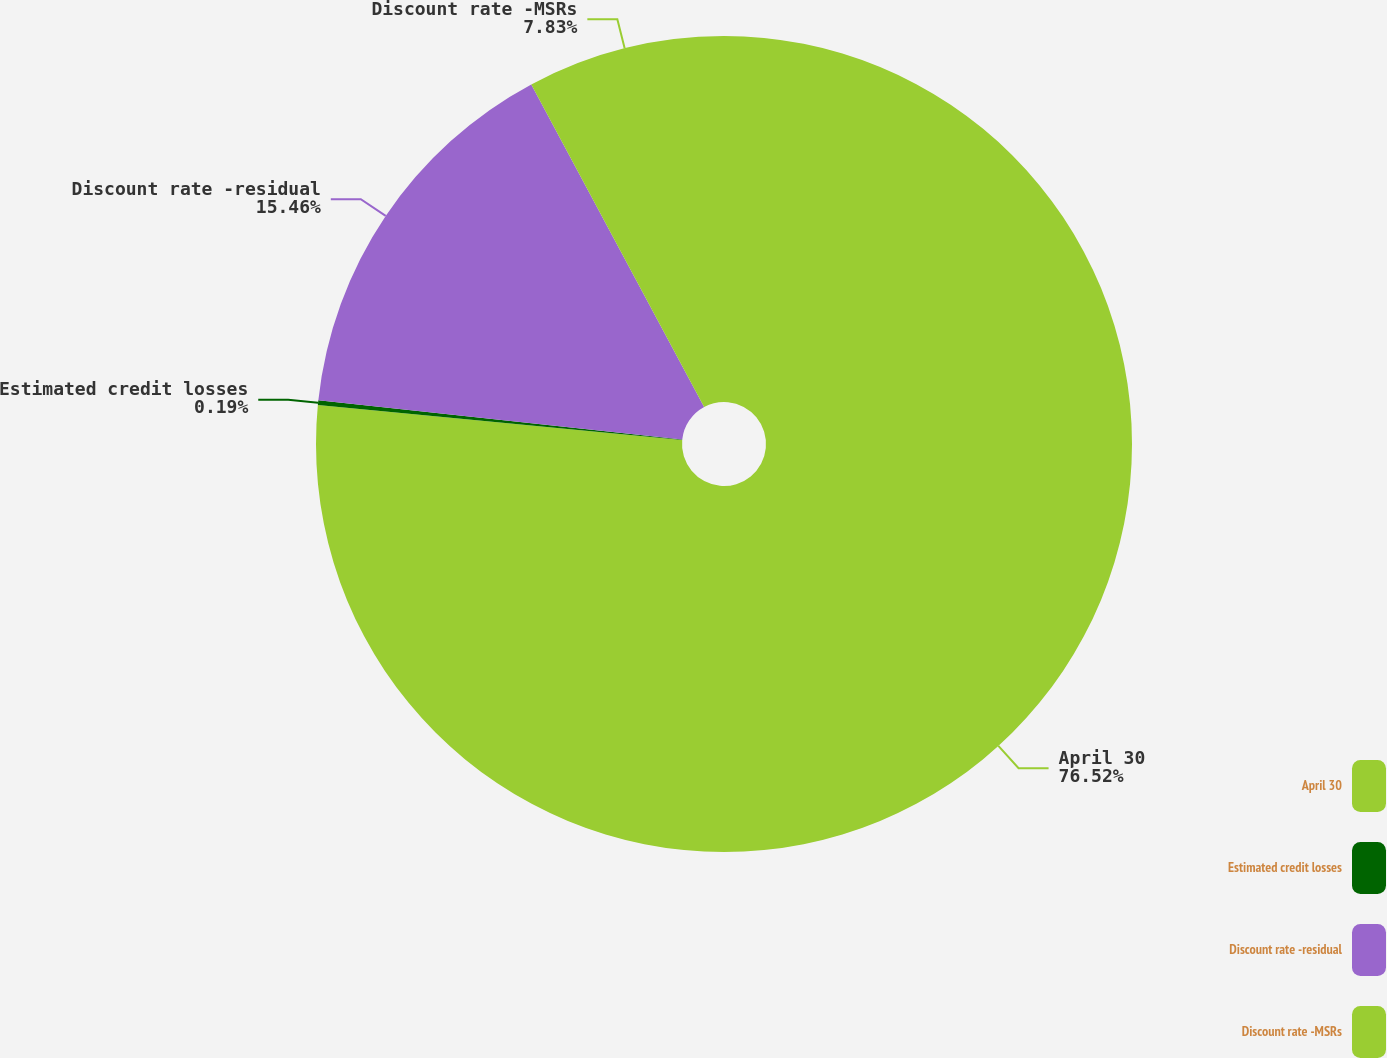Convert chart to OTSL. <chart><loc_0><loc_0><loc_500><loc_500><pie_chart><fcel>April 30<fcel>Estimated credit losses<fcel>Discount rate -residual<fcel>Discount rate -MSRs<nl><fcel>76.52%<fcel>0.19%<fcel>15.46%<fcel>7.83%<nl></chart> 